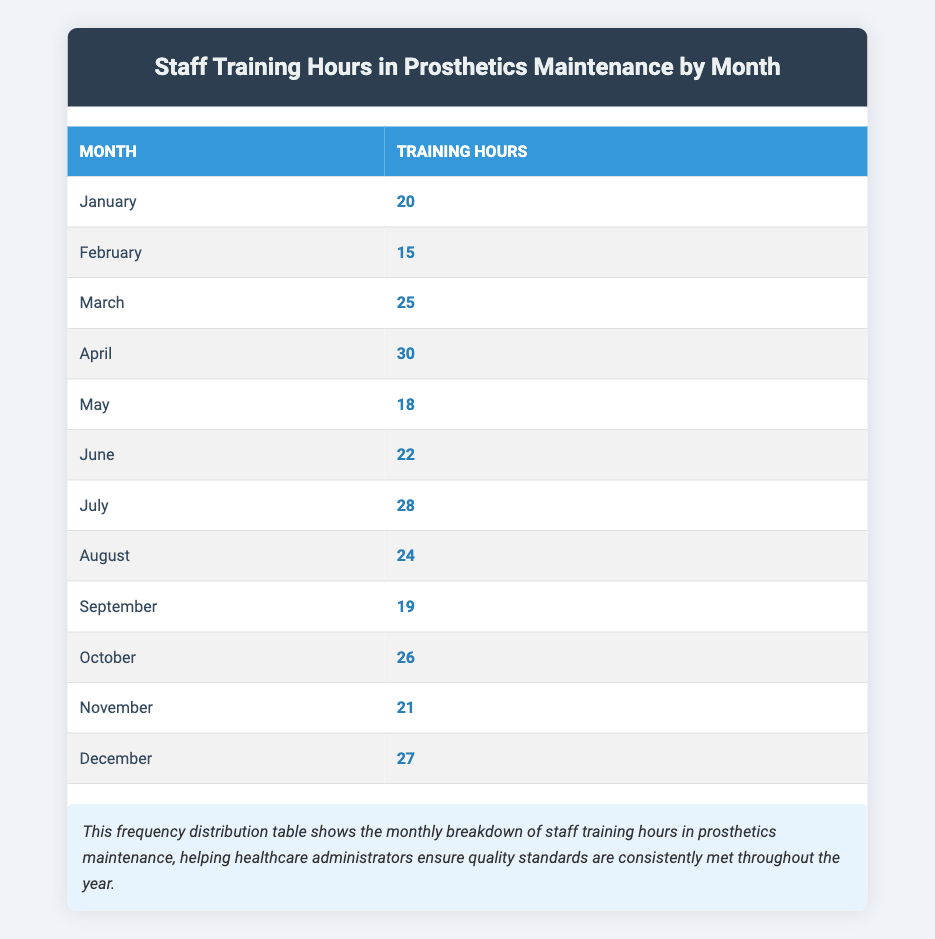What is the highest number of training hours recorded in a month? Looking at the hours listed for each month, April has the highest value at 30 hours.
Answer: 30 What is the total number of training hours across all months? To find the total, add the hours for each month: 20 + 15 + 25 + 30 + 18 + 22 + 28 + 24 + 19 + 26 + 21 + 27 =  25 + 30 + 70 + 21 + 79 = 310. The total is therefore 310 hours.
Answer: 310 In which month did staff receive the least training hours? A review of the training hours shows that February has the lowest value at 15 hours.
Answer: February Is the average training time per month more than 20 hours? To calculate the average, sum the hours to get 310, then divide by 12 (the number of months): 310/12 = 25.83. Since 25.83 is more than 20, the answer is yes.
Answer: Yes Which month has hours closest to the average? First, calculate the average at approximately 25.83 hours. Then, compare each month to find the closest values. April has 30, March has 25, and October has 26, with October being the closest to the average at just 0.17 hours difference.
Answer: October What is the difference in training hours between the month with the highest and the month with the lowest? The month with the highest hours is April with 30 hours, while the month with the lowest is February with 15 hours. The difference is 30 - 15 = 15 hours.
Answer: 15 Are the total training hours in the first half of the year greater than or equal to those in the second half? First, calculate the total for January to June (20 + 15 + 25 + 30 + 18 + 22 = 130) and for July to December (28 + 24 + 19 + 26 + 21 + 27 = 145). Since 130 is less than 145, the answer is no.
Answer: No How many months recorded more than 20 training hours? Review the hours to find which months exceed 20 hours: April, March, July, August, October, December. Counting these gives a total of 6 months surpassing 20 hours.
Answer: 6 What percentage of the total training hours was recorded in December? December has 27 hours. To find the percentage, calculate (27/310)*100 = 8.71%. Therefore, December constitutes approximately 8.71% of the total training hours.
Answer: 8.71% 